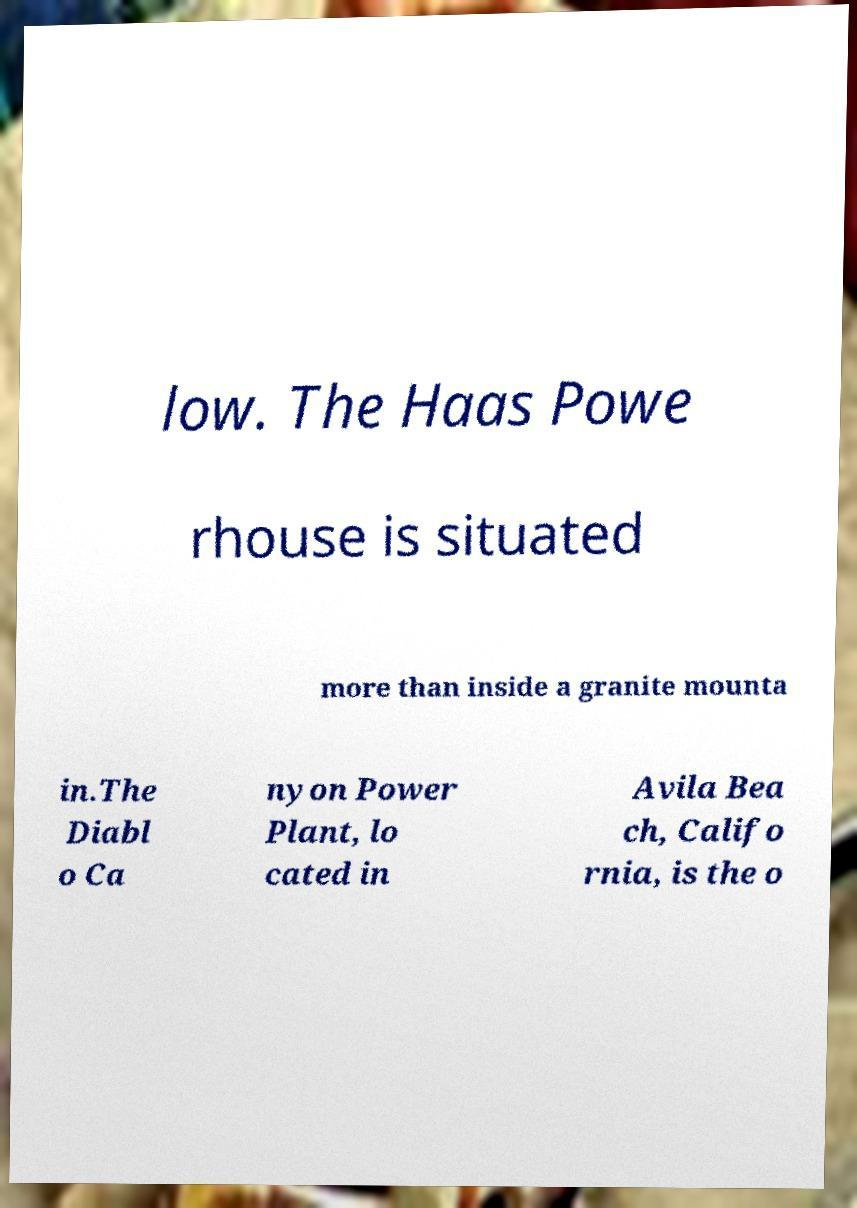What messages or text are displayed in this image? I need them in a readable, typed format. low. The Haas Powe rhouse is situated more than inside a granite mounta in.The Diabl o Ca nyon Power Plant, lo cated in Avila Bea ch, Califo rnia, is the o 